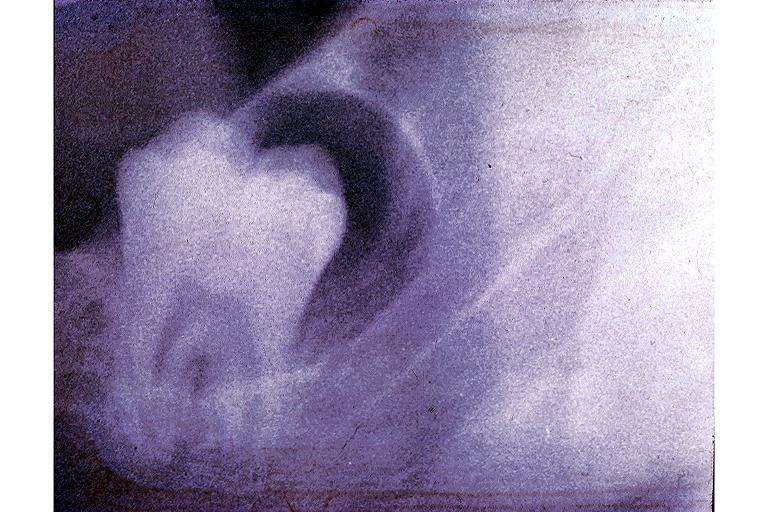does infiltrative process show dentigerous cyst?
Answer the question using a single word or phrase. No 